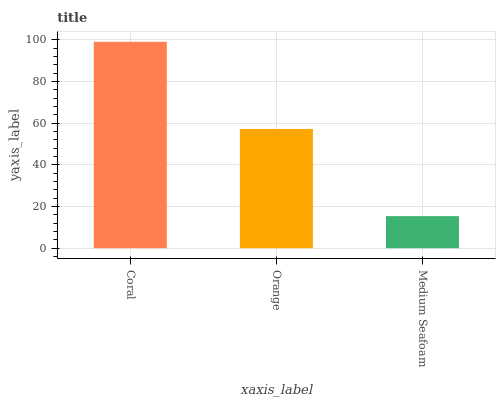Is Medium Seafoam the minimum?
Answer yes or no. Yes. Is Coral the maximum?
Answer yes or no. Yes. Is Orange the minimum?
Answer yes or no. No. Is Orange the maximum?
Answer yes or no. No. Is Coral greater than Orange?
Answer yes or no. Yes. Is Orange less than Coral?
Answer yes or no. Yes. Is Orange greater than Coral?
Answer yes or no. No. Is Coral less than Orange?
Answer yes or no. No. Is Orange the high median?
Answer yes or no. Yes. Is Orange the low median?
Answer yes or no. Yes. Is Medium Seafoam the high median?
Answer yes or no. No. Is Coral the low median?
Answer yes or no. No. 